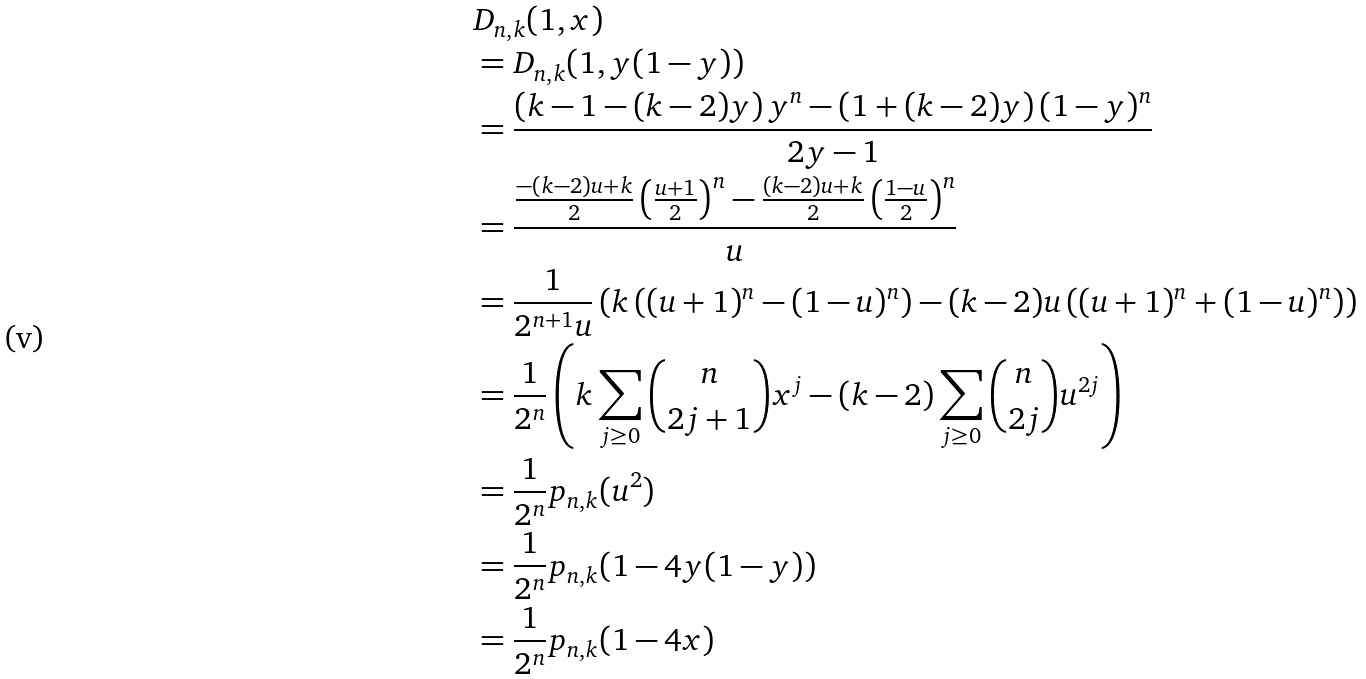<formula> <loc_0><loc_0><loc_500><loc_500>& D _ { n , k } ( 1 , x ) \\ & = D _ { n , k } ( 1 , y ( 1 - y ) ) \\ & = \frac { \left ( k - 1 - ( k - 2 ) y \right ) y ^ { n } - \left ( 1 + ( k - 2 ) y \right ) ( 1 - y ) ^ { n } } { 2 y - 1 } \\ & = \frac { \frac { - ( k - 2 ) u + k } { 2 } \left ( \frac { u + 1 } { 2 } \right ) ^ { n } - \frac { ( k - 2 ) u + k } { 2 } \left ( \frac { 1 - u } { 2 } \right ) ^ { n } } { u } \\ & = \frac { 1 } { 2 ^ { n + 1 } u } \left ( k \left ( ( u + 1 ) ^ { n } - ( 1 - u ) ^ { n } \right ) - ( k - 2 ) u \left ( ( u + 1 ) ^ { n } + ( 1 - u ) ^ { n } \right ) \right ) \\ & = \frac { 1 } { 2 ^ { n } } \left ( k \sum _ { j \geq 0 } \binom { n } { 2 j + 1 } x ^ { j } - ( k - 2 ) \sum _ { j \geq 0 } \binom { n } { 2 j } u ^ { 2 j } \right ) \\ & = \frac { 1 } { 2 ^ { n } } p _ { n , k } ( u ^ { 2 } ) \\ & = \frac { 1 } { 2 ^ { n } } p _ { n , k } ( 1 - 4 y ( 1 - y ) ) \\ & = \frac { 1 } { 2 ^ { n } } p _ { n , k } ( 1 - 4 x )</formula> 